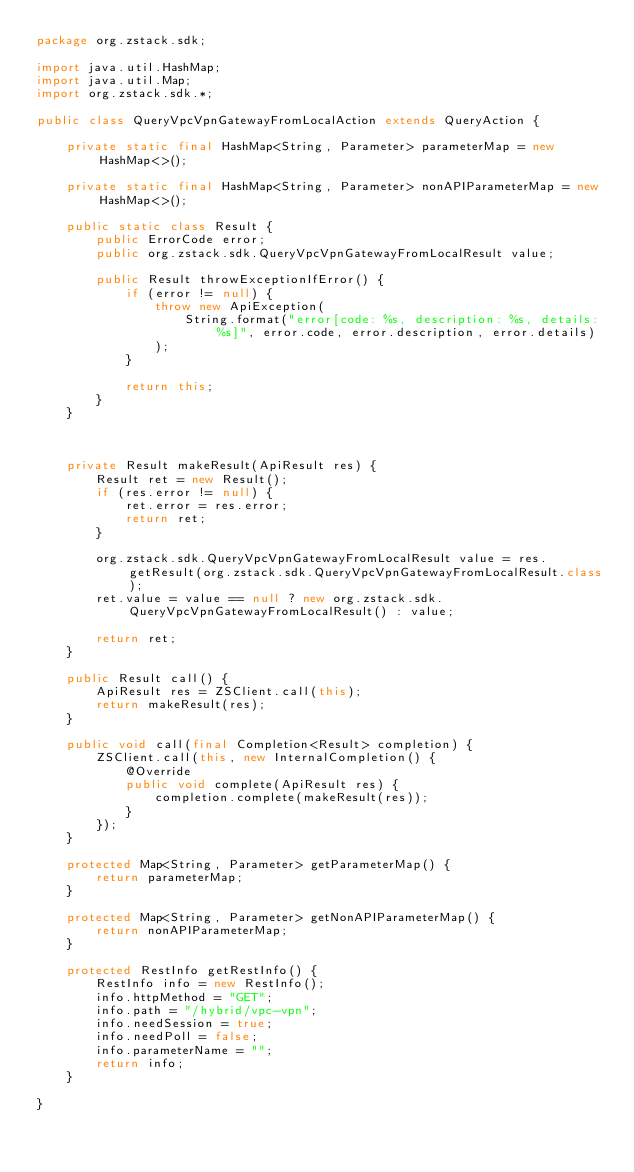Convert code to text. <code><loc_0><loc_0><loc_500><loc_500><_Java_>package org.zstack.sdk;

import java.util.HashMap;
import java.util.Map;
import org.zstack.sdk.*;

public class QueryVpcVpnGatewayFromLocalAction extends QueryAction {

    private static final HashMap<String, Parameter> parameterMap = new HashMap<>();

    private static final HashMap<String, Parameter> nonAPIParameterMap = new HashMap<>();

    public static class Result {
        public ErrorCode error;
        public org.zstack.sdk.QueryVpcVpnGatewayFromLocalResult value;

        public Result throwExceptionIfError() {
            if (error != null) {
                throw new ApiException(
                    String.format("error[code: %s, description: %s, details: %s]", error.code, error.description, error.details)
                );
            }
            
            return this;
        }
    }



    private Result makeResult(ApiResult res) {
        Result ret = new Result();
        if (res.error != null) {
            ret.error = res.error;
            return ret;
        }
        
        org.zstack.sdk.QueryVpcVpnGatewayFromLocalResult value = res.getResult(org.zstack.sdk.QueryVpcVpnGatewayFromLocalResult.class);
        ret.value = value == null ? new org.zstack.sdk.QueryVpcVpnGatewayFromLocalResult() : value; 

        return ret;
    }

    public Result call() {
        ApiResult res = ZSClient.call(this);
        return makeResult(res);
    }

    public void call(final Completion<Result> completion) {
        ZSClient.call(this, new InternalCompletion() {
            @Override
            public void complete(ApiResult res) {
                completion.complete(makeResult(res));
            }
        });
    }

    protected Map<String, Parameter> getParameterMap() {
        return parameterMap;
    }

    protected Map<String, Parameter> getNonAPIParameterMap() {
        return nonAPIParameterMap;
    }

    protected RestInfo getRestInfo() {
        RestInfo info = new RestInfo();
        info.httpMethod = "GET";
        info.path = "/hybrid/vpc-vpn";
        info.needSession = true;
        info.needPoll = false;
        info.parameterName = "";
        return info;
    }

}
</code> 